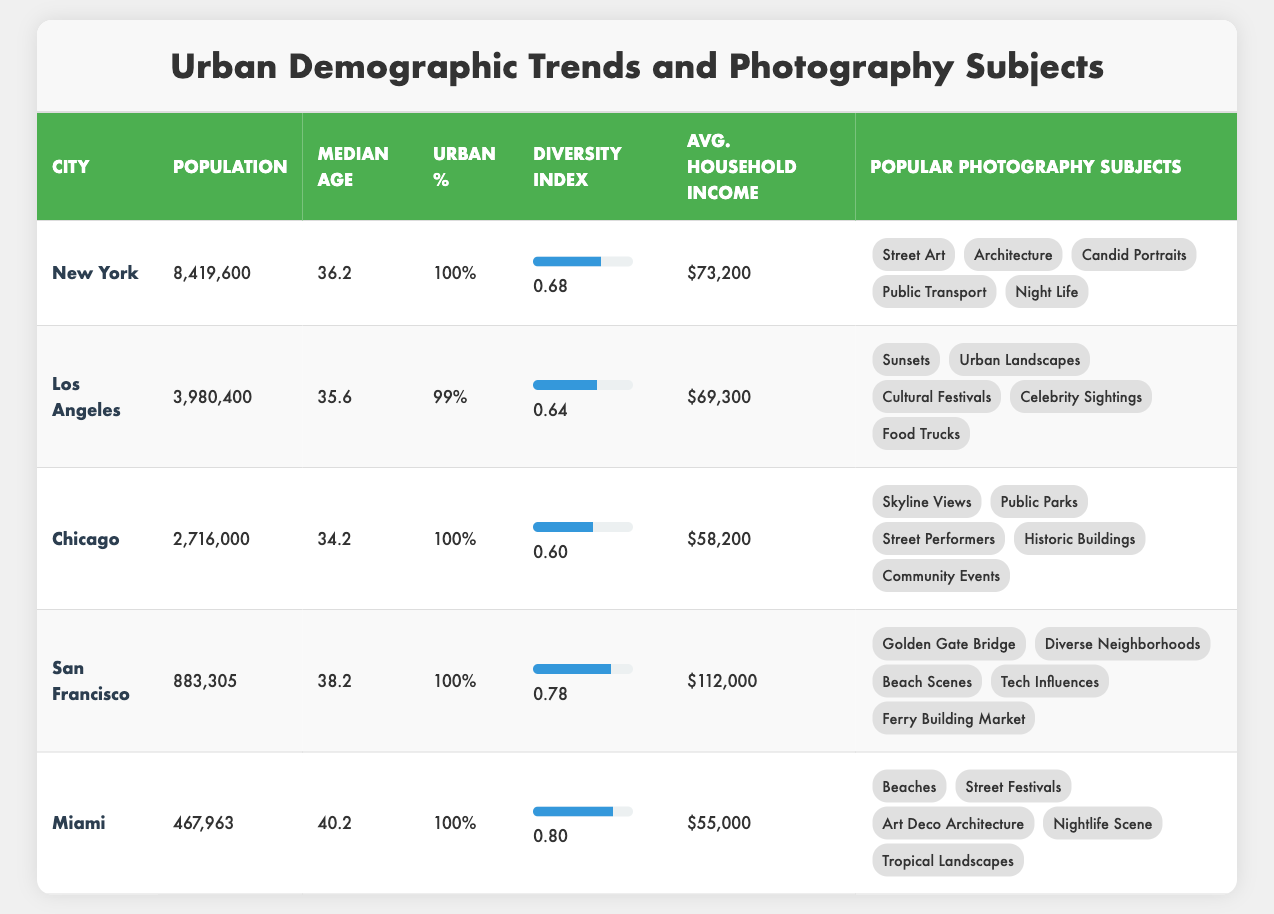What is the population of Los Angeles? In the table, the row for Los Angeles lists its population directly. The value stated there is 3,980,400.
Answer: 3,980,400 Which city has the highest diversity index? By comparing the diversity index values in the table, Miami has the highest index at 0.80, followed closely by San Francisco at 0.78.
Answer: Miami What is the median age of Chicago? The table displays the median age for each city, and for Chicago, it is listed as 34.2.
Answer: 34.2 How does the average household income of San Francisco compare to that of Miami? The average household income for San Francisco is $112,000, while for Miami, it is $55,000. The difference is calculated as $112,000 - $55,000 = $57,000. Thus, San Francisco's income is significantly higher than Miami's.
Answer: $57,000 Are public parks a popular photography subject in Chicago? Referring to the table, 'Public Parks' is explicitly listed under the popular photography subjects for Chicago. Therefore, the statement is true.
Answer: Yes What is the total urban population of all the cities listed in the table? The populations of all cities are added together: 8,419,600 (New York) + 3,980,400 (Los Angeles) + 2,716,000 (Chicago) + 883,305 (San Francisco) + 467,963 (Miami) = 16,467,268. Thus, the urban population total is 16,467,268.
Answer: 16,467,268 Which city among those listed has the lowest average household income? By looking at the average household income for each city, Miami has the lowest at $55,000, compared to the others listed.
Answer: Miami Which city has the second highest median age? From the median age values, San Francisco has the highest at 38.2 years, and Miami has the second highest at 40.2 years. Hence, Miami is the second highest.
Answer: Miami 